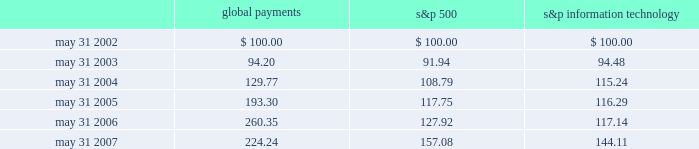Stock performance graph the following line-graph presentation compares our cumulative shareholder returns with the standard & poor 2019s information technology index and the standard & poor 2019s 500 stock index for the past five years .
The line graph assumes the investment of $ 100 in our common stock , the standard & poor 2019s information technology index , and the standard & poor 2019s 500 stock index on may 31 , 2002 and assumes reinvestment of all dividends .
Comparison of 5 year cumulative total return* among global payments inc. , the s&p 500 index and the s&p information technology index 5/02 5/03 5/04 5/05 5/06 5/07 global payments inc .
S&p 500 s&p information technology * $ 100 invested on 5/31/02 in stock or index-including reinvestment of dividends .
Fiscal year ending may 31 .
Global payments s&p 500 information technology .
Issuer purchases of equity securities on april 5 , 2007 , our board of directors authorized repurchases of our common stock in an amount up to $ 100 million .
The board has authorized us to purchase shares from time to time as market conditions permit .
There is no expiration date with respect to this authorization .
No amounts have been repurchased during the fiscal year ended may 31 , 2007. .
In comparison to overall information technology sector , how much percentage would global payments have earned the investor .? 
Rationale: to calculate how much greater the return was for global payments , one must find the percentage gain of the s&p information technology and global payments . then one must subtract these two percentages to find the change between the two .
Computations: ((224.24 - 100) - (144.11 - 100))
Answer: 80.13. 